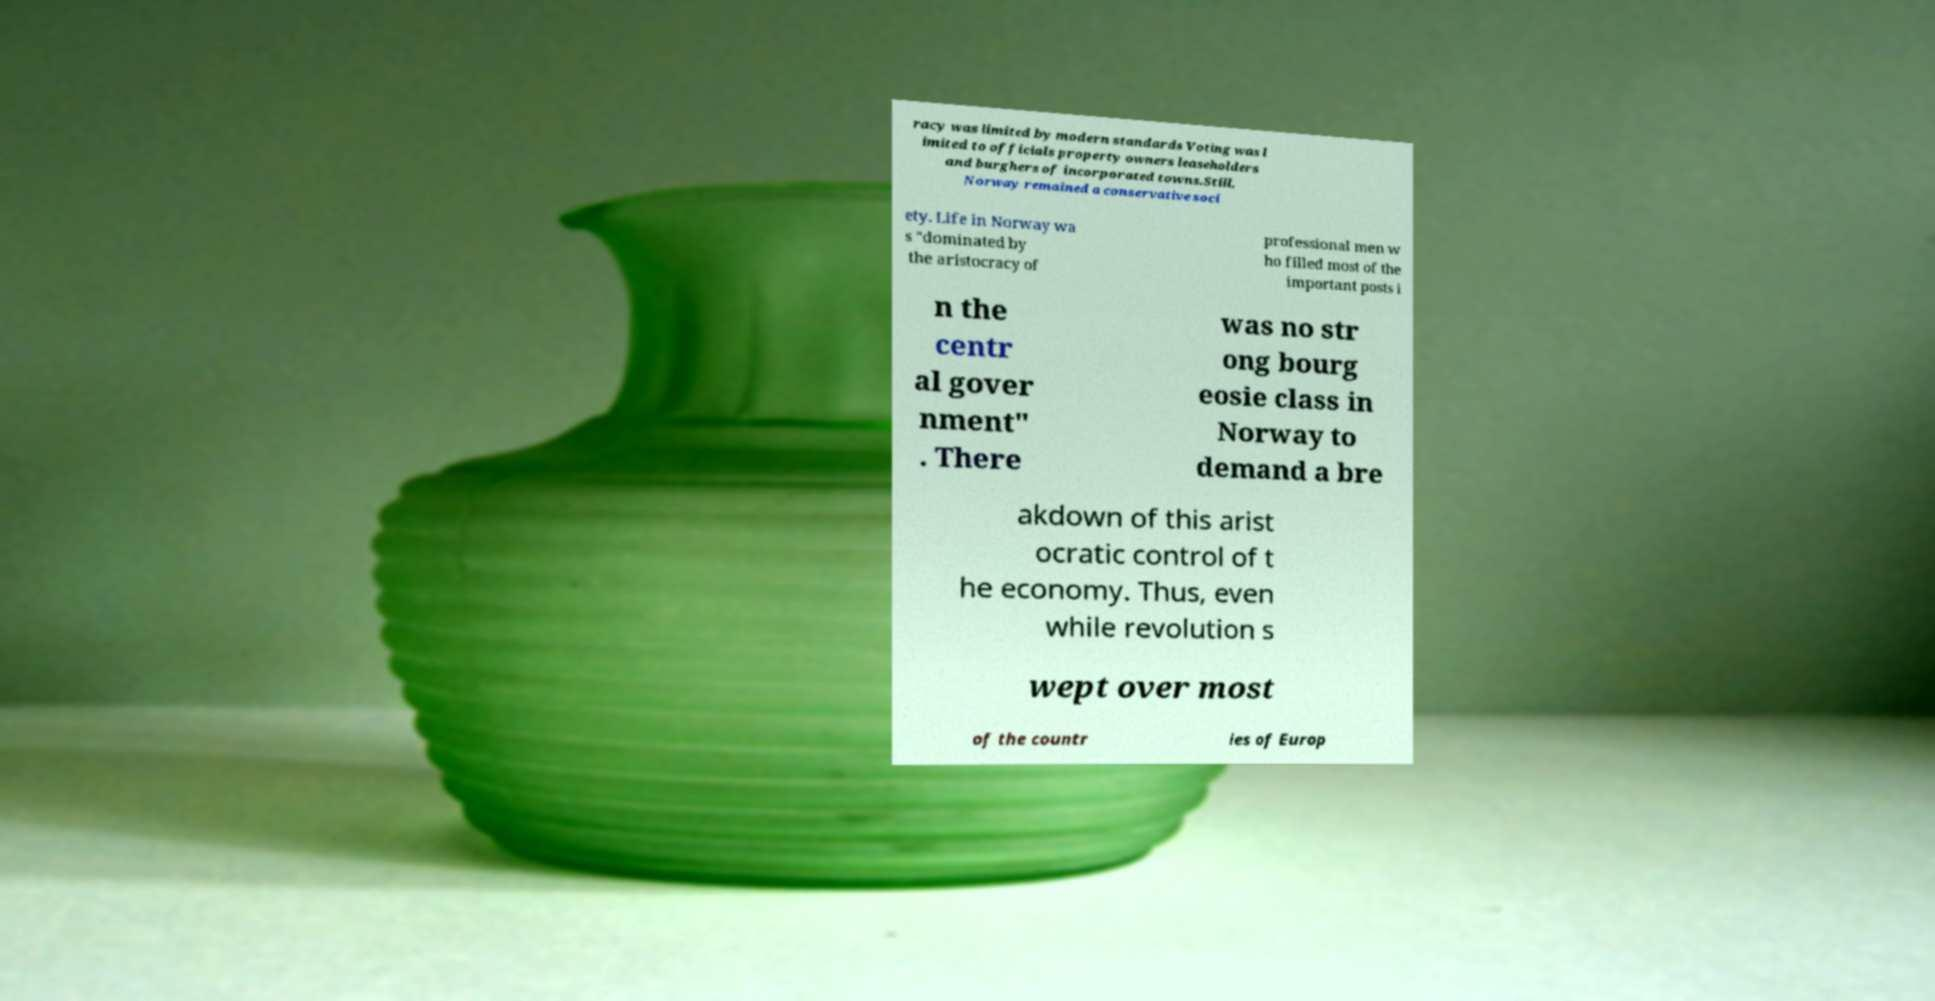Could you assist in decoding the text presented in this image and type it out clearly? racy was limited by modern standards Voting was l imited to officials property owners leaseholders and burghers of incorporated towns.Still, Norway remained a conservative soci ety. Life in Norway wa s "dominated by the aristocracy of professional men w ho filled most of the important posts i n the centr al gover nment" . There was no str ong bourg eosie class in Norway to demand a bre akdown of this arist ocratic control of t he economy. Thus, even while revolution s wept over most of the countr ies of Europ 